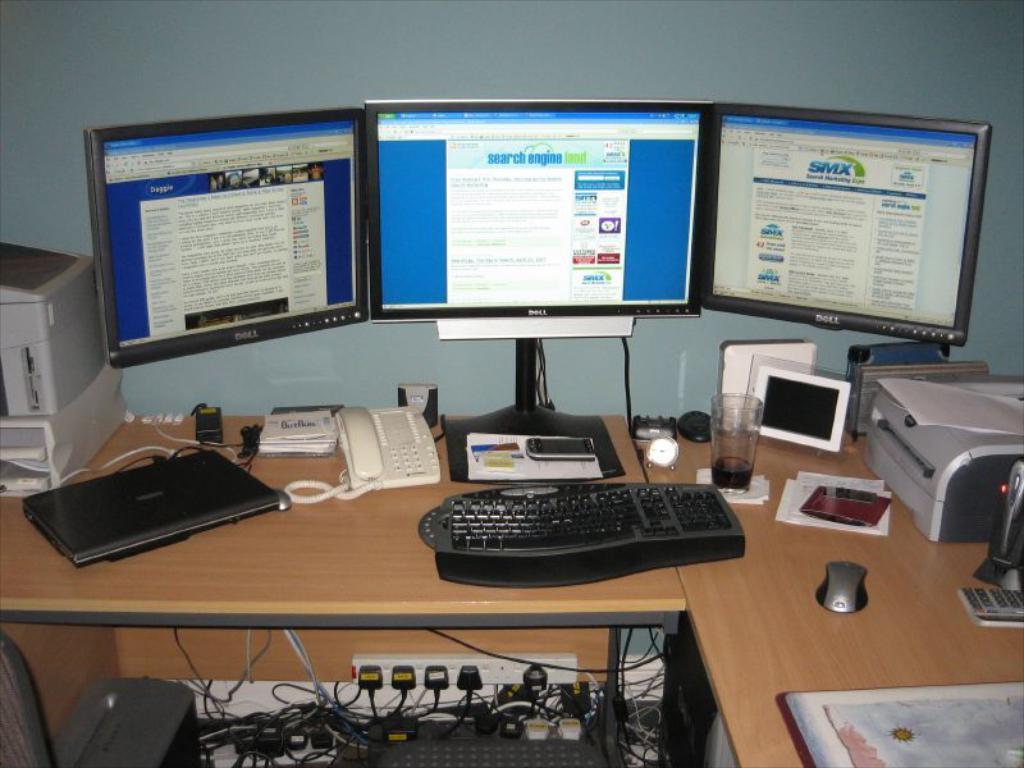Please provide a concise description of this image. In this image, There is a table which is in yellow color on that table there is a keyboard which is in black color and there is a laptop in black color, There is a telephone in white color on the table, There are some computer kept on the table, There is a glass on the table, In the right side there is a printer in white color, In the background there is a white color wall. 